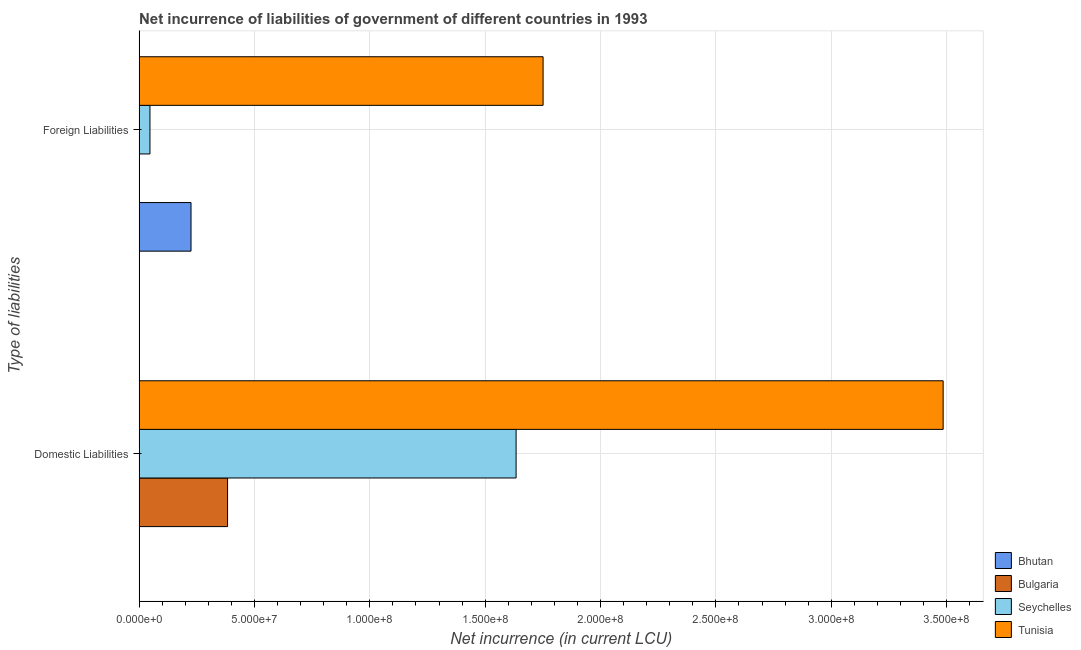How many different coloured bars are there?
Keep it short and to the point. 4. Are the number of bars per tick equal to the number of legend labels?
Offer a terse response. No. How many bars are there on the 2nd tick from the top?
Offer a very short reply. 3. How many bars are there on the 1st tick from the bottom?
Make the answer very short. 3. What is the label of the 2nd group of bars from the top?
Your answer should be compact. Domestic Liabilities. Across all countries, what is the maximum net incurrence of foreign liabilities?
Provide a short and direct response. 1.75e+08. Across all countries, what is the minimum net incurrence of domestic liabilities?
Your response must be concise. 0. In which country was the net incurrence of foreign liabilities maximum?
Offer a very short reply. Tunisia. What is the total net incurrence of domestic liabilities in the graph?
Offer a very short reply. 5.50e+08. What is the difference between the net incurrence of domestic liabilities in Seychelles and that in Tunisia?
Your response must be concise. -1.85e+08. What is the difference between the net incurrence of domestic liabilities in Bhutan and the net incurrence of foreign liabilities in Bulgaria?
Provide a succinct answer. 0. What is the average net incurrence of foreign liabilities per country?
Ensure brevity in your answer.  5.06e+07. What is the difference between the net incurrence of domestic liabilities and net incurrence of foreign liabilities in Tunisia?
Your answer should be compact. 1.73e+08. In how many countries, is the net incurrence of foreign liabilities greater than 250000000 LCU?
Give a very brief answer. 0. What is the ratio of the net incurrence of domestic liabilities in Tunisia to that in Seychelles?
Ensure brevity in your answer.  2.13. How many bars are there?
Offer a very short reply. 6. Are all the bars in the graph horizontal?
Provide a succinct answer. Yes. Where does the legend appear in the graph?
Make the answer very short. Bottom right. How many legend labels are there?
Your response must be concise. 4. What is the title of the graph?
Ensure brevity in your answer.  Net incurrence of liabilities of government of different countries in 1993. What is the label or title of the X-axis?
Ensure brevity in your answer.  Net incurrence (in current LCU). What is the label or title of the Y-axis?
Keep it short and to the point. Type of liabilities. What is the Net incurrence (in current LCU) of Bhutan in Domestic Liabilities?
Your response must be concise. 0. What is the Net incurrence (in current LCU) of Bulgaria in Domestic Liabilities?
Offer a very short reply. 3.83e+07. What is the Net incurrence (in current LCU) of Seychelles in Domestic Liabilities?
Provide a short and direct response. 1.63e+08. What is the Net incurrence (in current LCU) of Tunisia in Domestic Liabilities?
Your response must be concise. 3.48e+08. What is the Net incurrence (in current LCU) of Bhutan in Foreign Liabilities?
Your answer should be very brief. 2.25e+07. What is the Net incurrence (in current LCU) in Seychelles in Foreign Liabilities?
Provide a short and direct response. 4.70e+06. What is the Net incurrence (in current LCU) of Tunisia in Foreign Liabilities?
Your response must be concise. 1.75e+08. Across all Type of liabilities, what is the maximum Net incurrence (in current LCU) in Bhutan?
Offer a terse response. 2.25e+07. Across all Type of liabilities, what is the maximum Net incurrence (in current LCU) in Bulgaria?
Your answer should be very brief. 3.83e+07. Across all Type of liabilities, what is the maximum Net incurrence (in current LCU) in Seychelles?
Make the answer very short. 1.63e+08. Across all Type of liabilities, what is the maximum Net incurrence (in current LCU) in Tunisia?
Ensure brevity in your answer.  3.48e+08. Across all Type of liabilities, what is the minimum Net incurrence (in current LCU) in Seychelles?
Provide a short and direct response. 4.70e+06. Across all Type of liabilities, what is the minimum Net incurrence (in current LCU) in Tunisia?
Offer a very short reply. 1.75e+08. What is the total Net incurrence (in current LCU) in Bhutan in the graph?
Offer a very short reply. 2.25e+07. What is the total Net incurrence (in current LCU) of Bulgaria in the graph?
Offer a very short reply. 3.83e+07. What is the total Net incurrence (in current LCU) of Seychelles in the graph?
Keep it short and to the point. 1.68e+08. What is the total Net incurrence (in current LCU) of Tunisia in the graph?
Keep it short and to the point. 5.24e+08. What is the difference between the Net incurrence (in current LCU) in Seychelles in Domestic Liabilities and that in Foreign Liabilities?
Ensure brevity in your answer.  1.59e+08. What is the difference between the Net incurrence (in current LCU) in Tunisia in Domestic Liabilities and that in Foreign Liabilities?
Your answer should be compact. 1.73e+08. What is the difference between the Net incurrence (in current LCU) in Bulgaria in Domestic Liabilities and the Net incurrence (in current LCU) in Seychelles in Foreign Liabilities?
Your response must be concise. 3.36e+07. What is the difference between the Net incurrence (in current LCU) in Bulgaria in Domestic Liabilities and the Net incurrence (in current LCU) in Tunisia in Foreign Liabilities?
Ensure brevity in your answer.  -1.37e+08. What is the difference between the Net incurrence (in current LCU) in Seychelles in Domestic Liabilities and the Net incurrence (in current LCU) in Tunisia in Foreign Liabilities?
Offer a very short reply. -1.17e+07. What is the average Net incurrence (in current LCU) of Bhutan per Type of liabilities?
Offer a very short reply. 1.12e+07. What is the average Net incurrence (in current LCU) of Bulgaria per Type of liabilities?
Provide a succinct answer. 1.92e+07. What is the average Net incurrence (in current LCU) of Seychelles per Type of liabilities?
Ensure brevity in your answer.  8.40e+07. What is the average Net incurrence (in current LCU) of Tunisia per Type of liabilities?
Offer a terse response. 2.62e+08. What is the difference between the Net incurrence (in current LCU) of Bulgaria and Net incurrence (in current LCU) of Seychelles in Domestic Liabilities?
Your answer should be very brief. -1.25e+08. What is the difference between the Net incurrence (in current LCU) in Bulgaria and Net incurrence (in current LCU) in Tunisia in Domestic Liabilities?
Offer a very short reply. -3.10e+08. What is the difference between the Net incurrence (in current LCU) of Seychelles and Net incurrence (in current LCU) of Tunisia in Domestic Liabilities?
Provide a short and direct response. -1.85e+08. What is the difference between the Net incurrence (in current LCU) of Bhutan and Net incurrence (in current LCU) of Seychelles in Foreign Liabilities?
Offer a terse response. 1.78e+07. What is the difference between the Net incurrence (in current LCU) in Bhutan and Net incurrence (in current LCU) in Tunisia in Foreign Liabilities?
Ensure brevity in your answer.  -1.53e+08. What is the difference between the Net incurrence (in current LCU) of Seychelles and Net incurrence (in current LCU) of Tunisia in Foreign Liabilities?
Make the answer very short. -1.70e+08. What is the ratio of the Net incurrence (in current LCU) in Seychelles in Domestic Liabilities to that in Foreign Liabilities?
Make the answer very short. 34.77. What is the ratio of the Net incurrence (in current LCU) of Tunisia in Domestic Liabilities to that in Foreign Liabilities?
Your answer should be very brief. 1.99. What is the difference between the highest and the second highest Net incurrence (in current LCU) of Seychelles?
Give a very brief answer. 1.59e+08. What is the difference between the highest and the second highest Net incurrence (in current LCU) in Tunisia?
Give a very brief answer. 1.73e+08. What is the difference between the highest and the lowest Net incurrence (in current LCU) in Bhutan?
Your answer should be very brief. 2.25e+07. What is the difference between the highest and the lowest Net incurrence (in current LCU) of Bulgaria?
Ensure brevity in your answer.  3.83e+07. What is the difference between the highest and the lowest Net incurrence (in current LCU) of Seychelles?
Your response must be concise. 1.59e+08. What is the difference between the highest and the lowest Net incurrence (in current LCU) in Tunisia?
Your response must be concise. 1.73e+08. 